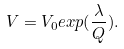<formula> <loc_0><loc_0><loc_500><loc_500>V = V _ { 0 } e x p ( \frac { \lambda } { Q } ) .</formula> 